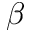<formula> <loc_0><loc_0><loc_500><loc_500>\beta</formula> 